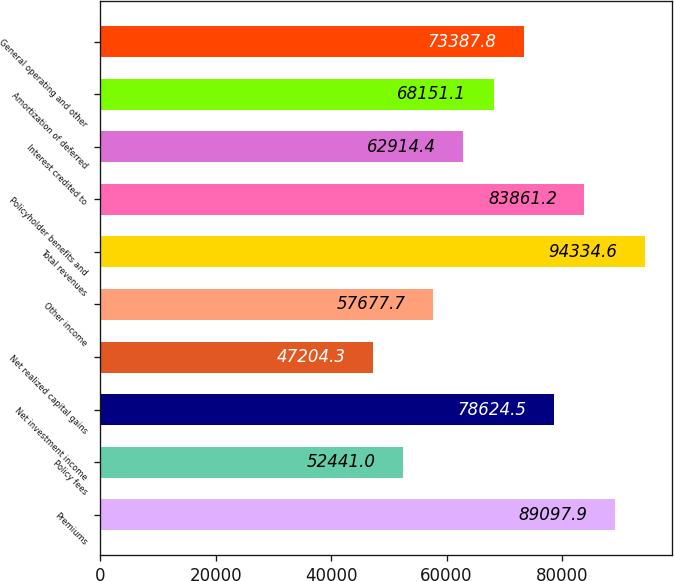Convert chart. <chart><loc_0><loc_0><loc_500><loc_500><bar_chart><fcel>Premiums<fcel>Policy fees<fcel>Net investment income<fcel>Net realized capital gains<fcel>Other income<fcel>Total revenues<fcel>Policyholder benefits and<fcel>Interest credited to<fcel>Amortization of deferred<fcel>General operating and other<nl><fcel>89097.9<fcel>52441<fcel>78624.5<fcel>47204.3<fcel>57677.7<fcel>94334.6<fcel>83861.2<fcel>62914.4<fcel>68151.1<fcel>73387.8<nl></chart> 